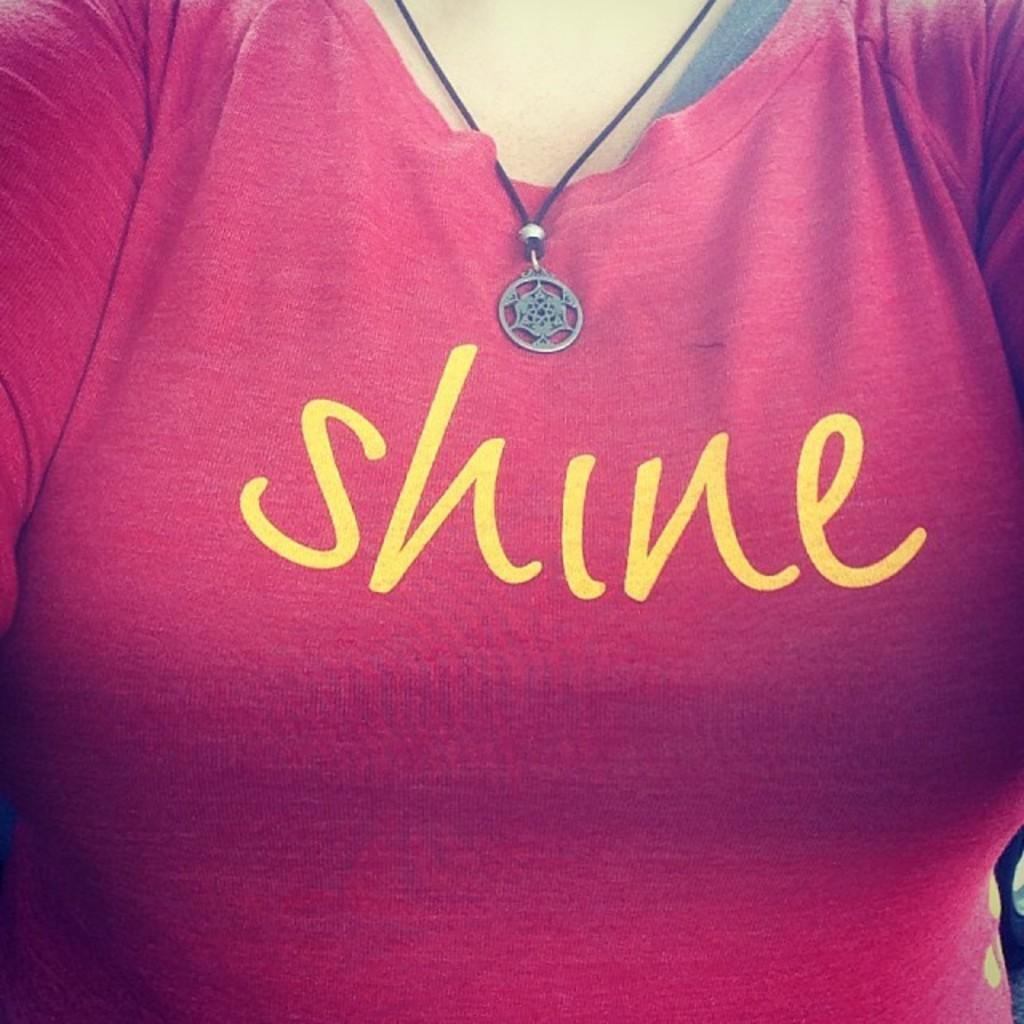What is present in the image? There is a person in the image. Can you describe the person's appearance? The person is wearing clothes and a neck chain. What is written or printed on the person's clothes? There is text on the clothes. How many bats are flying around the person in the image? There are no bats present in the image. Is the person standing on a mass of snow in the image? There is no snow or indication of snow in the image. 